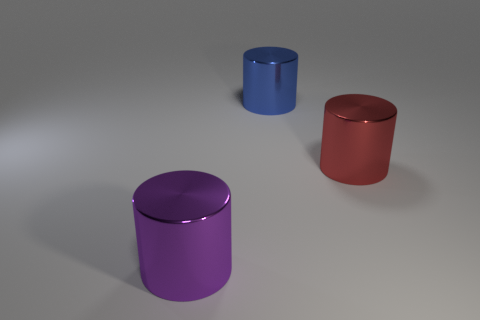How many other things are the same material as the large blue thing?
Ensure brevity in your answer.  2. Is the size of the object that is in front of the big red metal object the same as the metallic cylinder that is behind the red metallic cylinder?
Your response must be concise. Yes. What number of objects are large metallic things that are behind the big purple cylinder or things left of the big red object?
Your answer should be compact. 3. Is there anything else that has the same shape as the blue shiny thing?
Offer a very short reply. Yes. There is a large metal thing that is to the left of the blue metallic cylinder; is its color the same as the large object that is on the right side of the large blue thing?
Your answer should be compact. No. How many metallic objects are red things or blue objects?
Your answer should be compact. 2. The large object that is on the left side of the big metallic cylinder behind the big red metallic object is what shape?
Offer a very short reply. Cylinder. Is the large cylinder that is right of the large blue cylinder made of the same material as the purple object that is on the left side of the large blue thing?
Your answer should be very brief. Yes. What number of metallic things are in front of the large object on the right side of the large blue metallic thing?
Your answer should be compact. 1. There is a big metallic thing that is in front of the red object; is it the same shape as the object behind the red object?
Your response must be concise. Yes. 